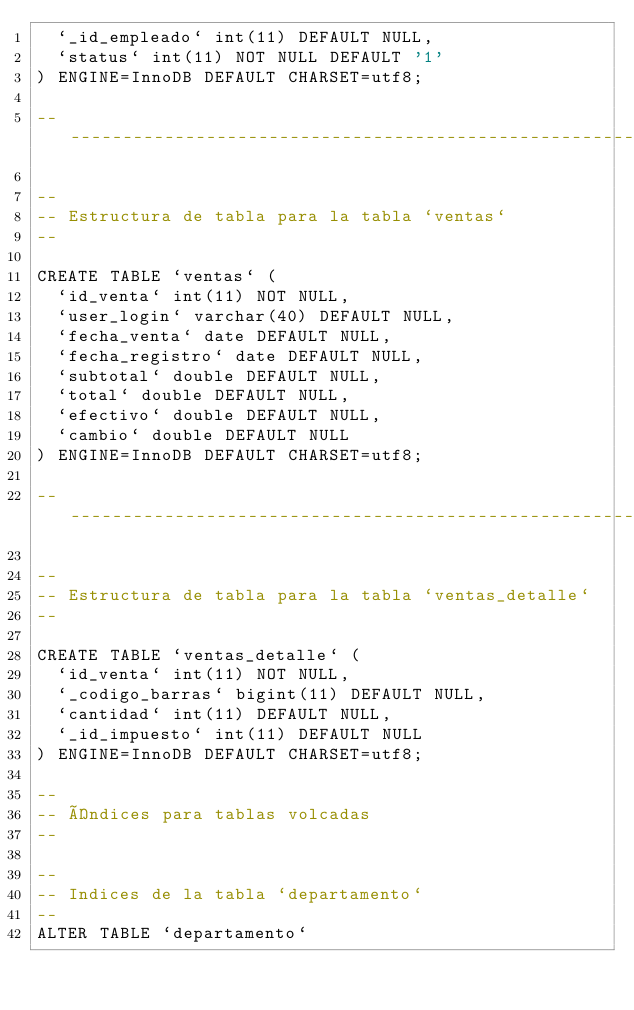Convert code to text. <code><loc_0><loc_0><loc_500><loc_500><_SQL_>  `_id_empleado` int(11) DEFAULT NULL,
  `status` int(11) NOT NULL DEFAULT '1'
) ENGINE=InnoDB DEFAULT CHARSET=utf8;

-- --------------------------------------------------------

--
-- Estructura de tabla para la tabla `ventas`
--

CREATE TABLE `ventas` (
  `id_venta` int(11) NOT NULL,
  `user_login` varchar(40) DEFAULT NULL,
  `fecha_venta` date DEFAULT NULL,
  `fecha_registro` date DEFAULT NULL,
  `subtotal` double DEFAULT NULL,
  `total` double DEFAULT NULL,
  `efectivo` double DEFAULT NULL,
  `cambio` double DEFAULT NULL
) ENGINE=InnoDB DEFAULT CHARSET=utf8;

-- --------------------------------------------------------

--
-- Estructura de tabla para la tabla `ventas_detalle`
--

CREATE TABLE `ventas_detalle` (
  `id_venta` int(11) NOT NULL,
  `_codigo_barras` bigint(11) DEFAULT NULL,
  `cantidad` int(11) DEFAULT NULL,
  `_id_impuesto` int(11) DEFAULT NULL
) ENGINE=InnoDB DEFAULT CHARSET=utf8;

--
-- Índices para tablas volcadas
--

--
-- Indices de la tabla `departamento`
--
ALTER TABLE `departamento`</code> 